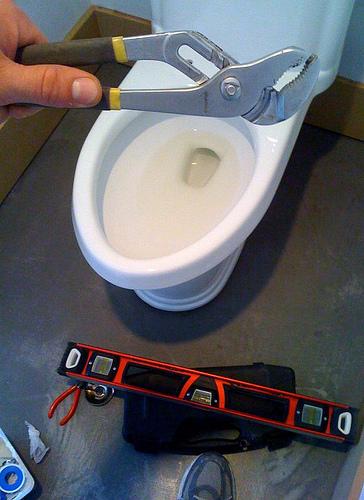Is the toilet being used?
Give a very brief answer. No. Is the toilet clean?
Give a very brief answer. Yes. Is there a level in the picture?
Be succinct. Yes. Is there a live fish in the image?
Concise answer only. No. 